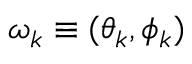<formula> <loc_0><loc_0><loc_500><loc_500>\omega _ { k } \equiv ( \theta _ { k } , \phi _ { k } )</formula> 